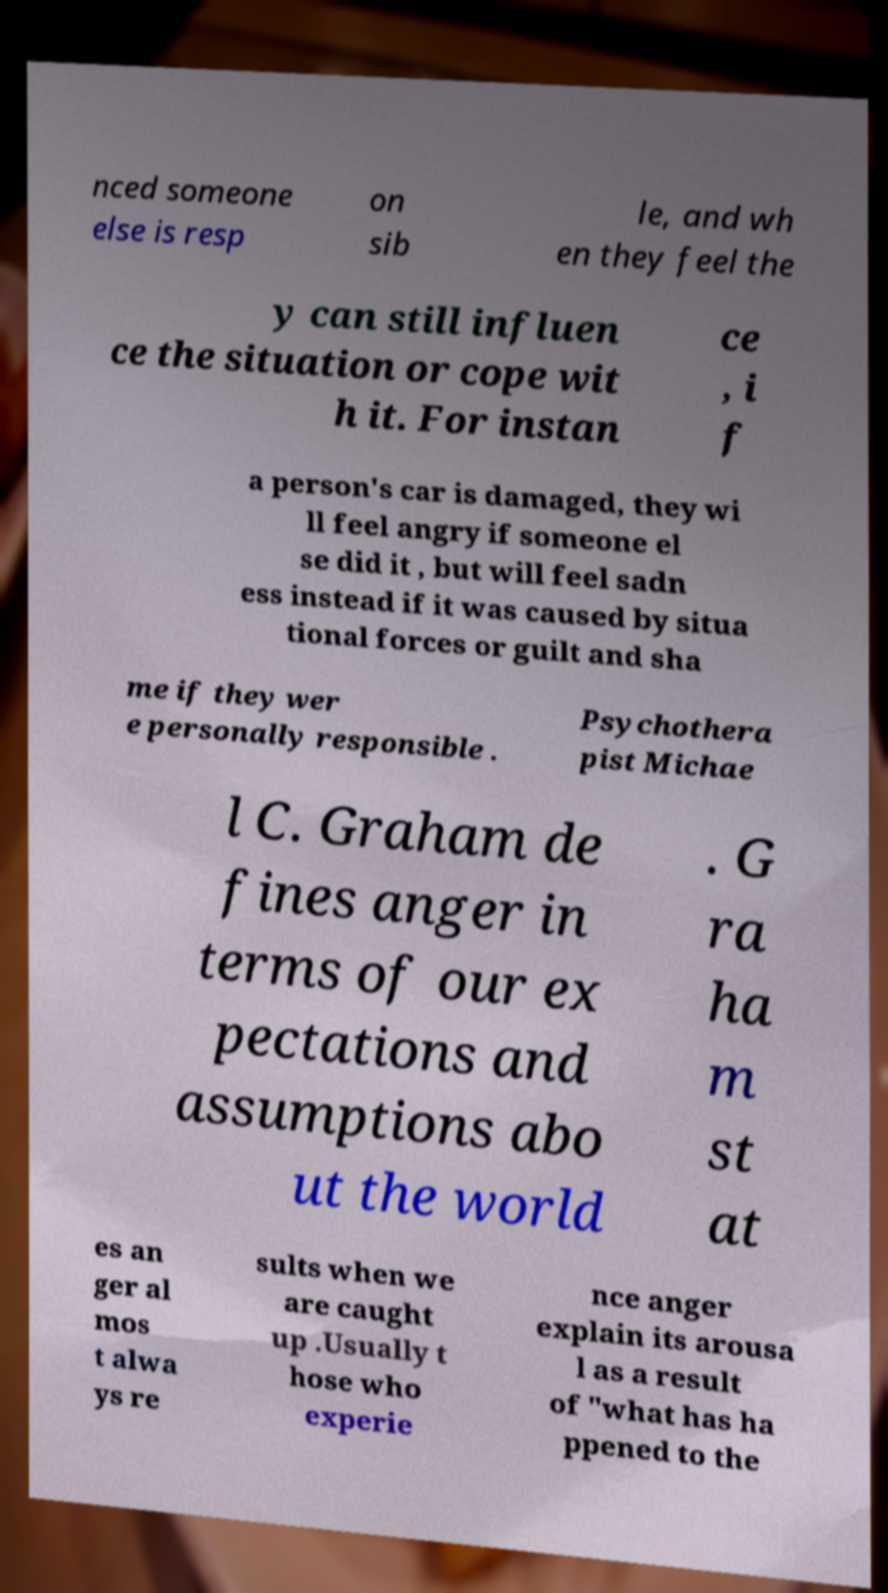Please read and relay the text visible in this image. What does it say? nced someone else is resp on sib le, and wh en they feel the y can still influen ce the situation or cope wit h it. For instan ce , i f a person's car is damaged, they wi ll feel angry if someone el se did it , but will feel sadn ess instead if it was caused by situa tional forces or guilt and sha me if they wer e personally responsible . Psychothera pist Michae l C. Graham de fines anger in terms of our ex pectations and assumptions abo ut the world . G ra ha m st at es an ger al mos t alwa ys re sults when we are caught up .Usually t hose who experie nce anger explain its arousa l as a result of "what has ha ppened to the 